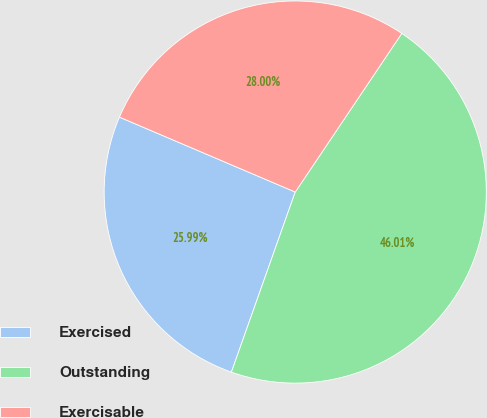Convert chart. <chart><loc_0><loc_0><loc_500><loc_500><pie_chart><fcel>Exercised<fcel>Outstanding<fcel>Exercisable<nl><fcel>25.99%<fcel>46.01%<fcel>28.0%<nl></chart> 